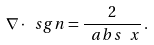<formula> <loc_0><loc_0><loc_500><loc_500>\nabla \cdot \ s g n = \frac { 2 } { \ a b s { \ x } } \, .</formula> 